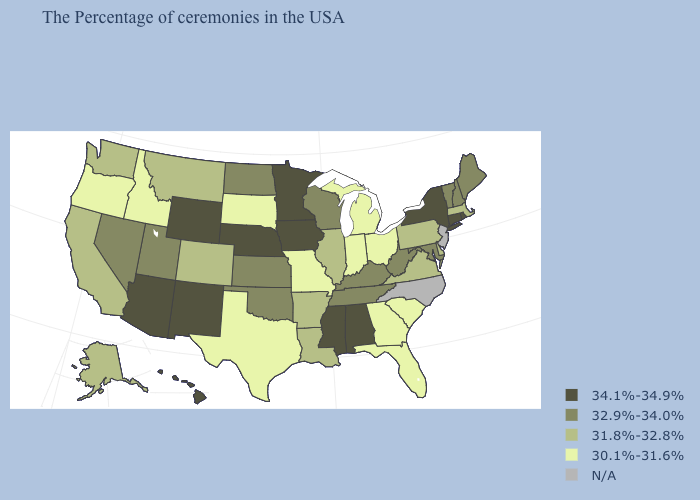What is the lowest value in states that border Wyoming?
Short answer required. 30.1%-31.6%. What is the value of Nebraska?
Concise answer only. 34.1%-34.9%. Among the states that border Kentucky , which have the lowest value?
Give a very brief answer. Ohio, Indiana, Missouri. Name the states that have a value in the range N/A?
Quick response, please. New Jersey, North Carolina. What is the lowest value in the West?
Be succinct. 30.1%-31.6%. Name the states that have a value in the range N/A?
Give a very brief answer. New Jersey, North Carolina. Does the first symbol in the legend represent the smallest category?
Give a very brief answer. No. Among the states that border Iowa , which have the lowest value?
Keep it brief. Missouri, South Dakota. Does the first symbol in the legend represent the smallest category?
Short answer required. No. Which states have the lowest value in the West?
Write a very short answer. Idaho, Oregon. What is the value of Georgia?
Quick response, please. 30.1%-31.6%. Does Arkansas have the lowest value in the South?
Write a very short answer. No. How many symbols are there in the legend?
Quick response, please. 5. What is the value of Connecticut?
Give a very brief answer. 34.1%-34.9%. 